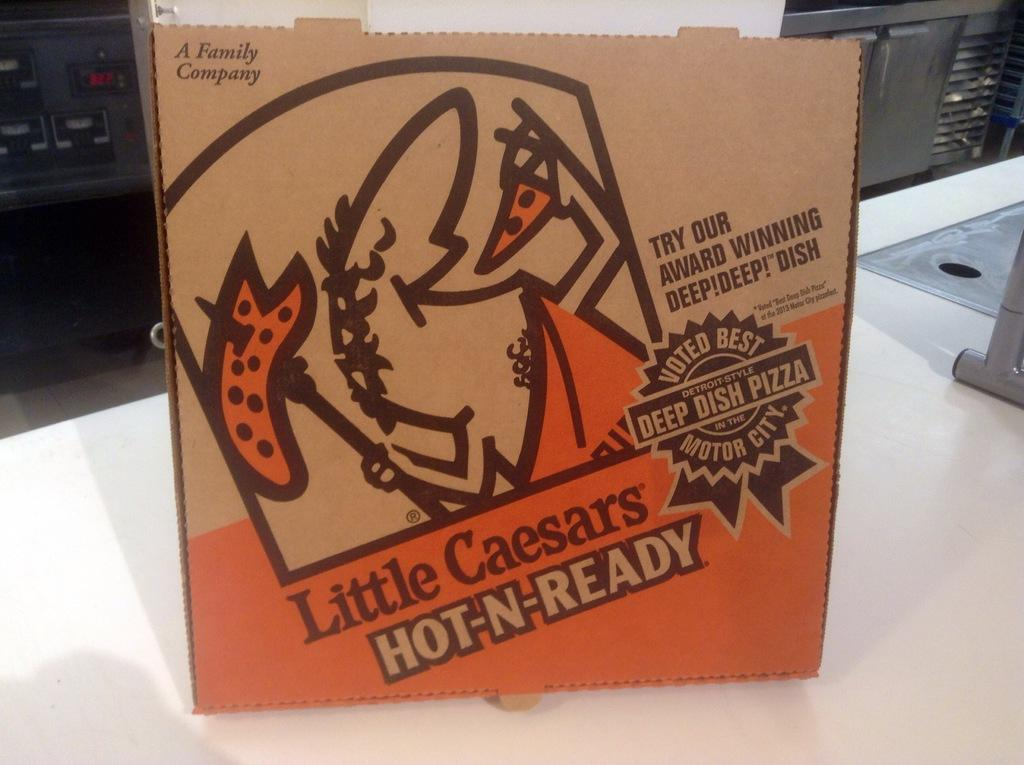<image>
Write a terse but informative summary of the picture. a close up of Little Caesars Hot N Ready pizza box 